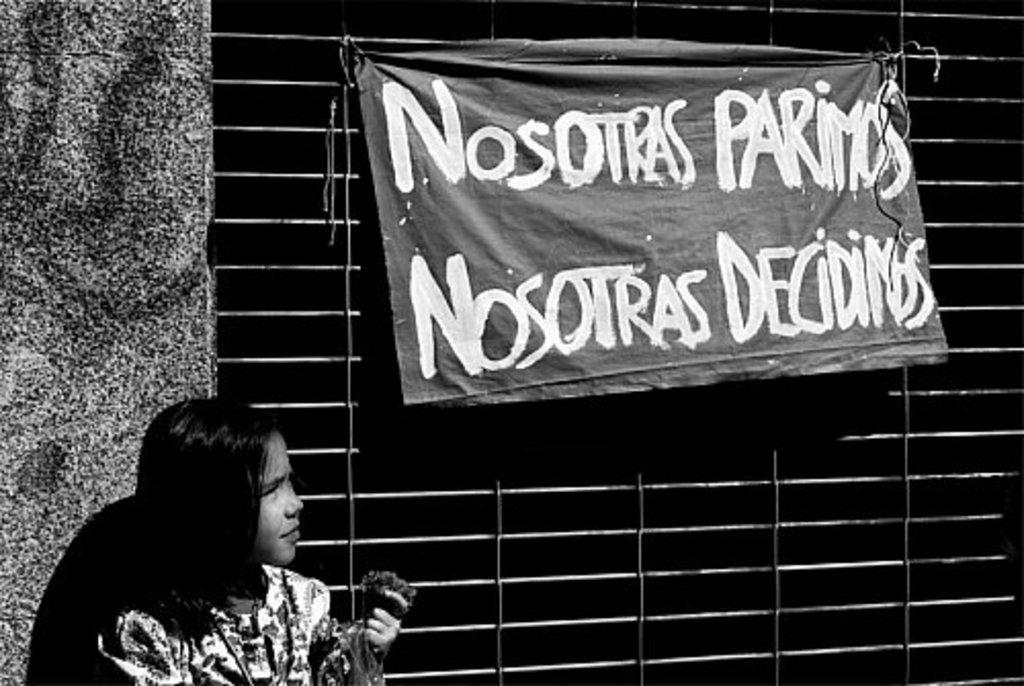What is the main subject of the image? The main subject of the image is a kid. Where is the kid located in the image? The kid is at the bottom of the image. What else can be seen in the middle of the image? There is a banner and grilles in the middle of the image. What is written on the banner? There is text on the banner. What is the color scheme of the image? The image is black and white. What type of furniture is visible in the image? There is no furniture present in the image. How many crates can be seen stacked in the image? There are no crates present in the image. 